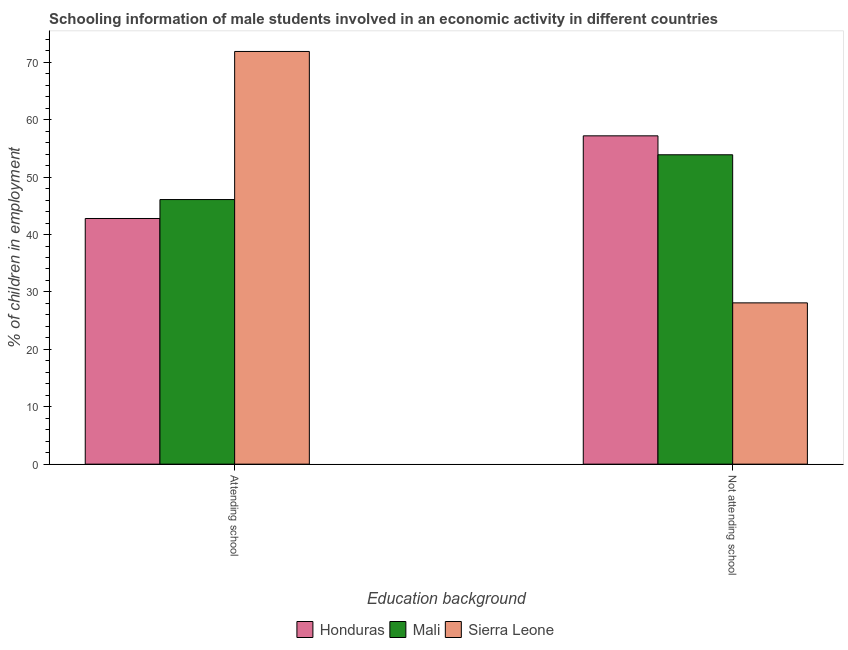Are the number of bars on each tick of the X-axis equal?
Keep it short and to the point. Yes. How many bars are there on the 2nd tick from the right?
Keep it short and to the point. 3. What is the label of the 1st group of bars from the left?
Keep it short and to the point. Attending school. What is the percentage of employed males who are not attending school in Honduras?
Make the answer very short. 57.2. Across all countries, what is the maximum percentage of employed males who are not attending school?
Keep it short and to the point. 57.2. Across all countries, what is the minimum percentage of employed males who are not attending school?
Make the answer very short. 28.1. In which country was the percentage of employed males who are attending school maximum?
Your answer should be very brief. Sierra Leone. In which country was the percentage of employed males who are attending school minimum?
Offer a terse response. Honduras. What is the total percentage of employed males who are attending school in the graph?
Offer a terse response. 160.8. What is the difference between the percentage of employed males who are attending school in Honduras and that in Sierra Leone?
Give a very brief answer. -29.1. What is the difference between the percentage of employed males who are attending school in Sierra Leone and the percentage of employed males who are not attending school in Mali?
Provide a succinct answer. 18. What is the average percentage of employed males who are not attending school per country?
Offer a very short reply. 46.4. What is the difference between the percentage of employed males who are attending school and percentage of employed males who are not attending school in Honduras?
Your answer should be compact. -14.4. In how many countries, is the percentage of employed males who are not attending school greater than 58 %?
Make the answer very short. 0. What is the ratio of the percentage of employed males who are attending school in Sierra Leone to that in Mali?
Your response must be concise. 1.56. Is the percentage of employed males who are not attending school in Honduras less than that in Mali?
Offer a terse response. No. In how many countries, is the percentage of employed males who are attending school greater than the average percentage of employed males who are attending school taken over all countries?
Provide a short and direct response. 1. What does the 1st bar from the left in Attending school represents?
Ensure brevity in your answer.  Honduras. What does the 1st bar from the right in Attending school represents?
Make the answer very short. Sierra Leone. Are all the bars in the graph horizontal?
Make the answer very short. No. How many countries are there in the graph?
Offer a terse response. 3. Are the values on the major ticks of Y-axis written in scientific E-notation?
Your answer should be very brief. No. Does the graph contain any zero values?
Your answer should be very brief. No. Does the graph contain grids?
Keep it short and to the point. No. How many legend labels are there?
Keep it short and to the point. 3. What is the title of the graph?
Offer a terse response. Schooling information of male students involved in an economic activity in different countries. Does "Iceland" appear as one of the legend labels in the graph?
Ensure brevity in your answer.  No. What is the label or title of the X-axis?
Give a very brief answer. Education background. What is the label or title of the Y-axis?
Provide a short and direct response. % of children in employment. What is the % of children in employment of Honduras in Attending school?
Make the answer very short. 42.8. What is the % of children in employment of Mali in Attending school?
Keep it short and to the point. 46.1. What is the % of children in employment of Sierra Leone in Attending school?
Your answer should be very brief. 71.9. What is the % of children in employment in Honduras in Not attending school?
Make the answer very short. 57.2. What is the % of children in employment of Mali in Not attending school?
Offer a terse response. 53.9. What is the % of children in employment in Sierra Leone in Not attending school?
Provide a short and direct response. 28.1. Across all Education background, what is the maximum % of children in employment in Honduras?
Offer a very short reply. 57.2. Across all Education background, what is the maximum % of children in employment of Mali?
Your answer should be very brief. 53.9. Across all Education background, what is the maximum % of children in employment of Sierra Leone?
Keep it short and to the point. 71.9. Across all Education background, what is the minimum % of children in employment in Honduras?
Keep it short and to the point. 42.8. Across all Education background, what is the minimum % of children in employment of Mali?
Give a very brief answer. 46.1. Across all Education background, what is the minimum % of children in employment in Sierra Leone?
Your response must be concise. 28.1. What is the total % of children in employment of Honduras in the graph?
Your answer should be very brief. 100. What is the total % of children in employment of Sierra Leone in the graph?
Provide a short and direct response. 100. What is the difference between the % of children in employment in Honduras in Attending school and that in Not attending school?
Your answer should be very brief. -14.4. What is the difference between the % of children in employment of Sierra Leone in Attending school and that in Not attending school?
Provide a short and direct response. 43.8. What is the difference between the % of children in employment of Honduras in Attending school and the % of children in employment of Mali in Not attending school?
Give a very brief answer. -11.1. What is the average % of children in employment in Honduras per Education background?
Ensure brevity in your answer.  50. What is the difference between the % of children in employment of Honduras and % of children in employment of Sierra Leone in Attending school?
Give a very brief answer. -29.1. What is the difference between the % of children in employment in Mali and % of children in employment in Sierra Leone in Attending school?
Give a very brief answer. -25.8. What is the difference between the % of children in employment in Honduras and % of children in employment in Mali in Not attending school?
Your response must be concise. 3.3. What is the difference between the % of children in employment in Honduras and % of children in employment in Sierra Leone in Not attending school?
Your response must be concise. 29.1. What is the difference between the % of children in employment of Mali and % of children in employment of Sierra Leone in Not attending school?
Give a very brief answer. 25.8. What is the ratio of the % of children in employment in Honduras in Attending school to that in Not attending school?
Give a very brief answer. 0.75. What is the ratio of the % of children in employment in Mali in Attending school to that in Not attending school?
Your answer should be very brief. 0.86. What is the ratio of the % of children in employment of Sierra Leone in Attending school to that in Not attending school?
Offer a very short reply. 2.56. What is the difference between the highest and the second highest % of children in employment in Honduras?
Keep it short and to the point. 14.4. What is the difference between the highest and the second highest % of children in employment of Sierra Leone?
Provide a short and direct response. 43.8. What is the difference between the highest and the lowest % of children in employment of Mali?
Ensure brevity in your answer.  7.8. What is the difference between the highest and the lowest % of children in employment in Sierra Leone?
Keep it short and to the point. 43.8. 